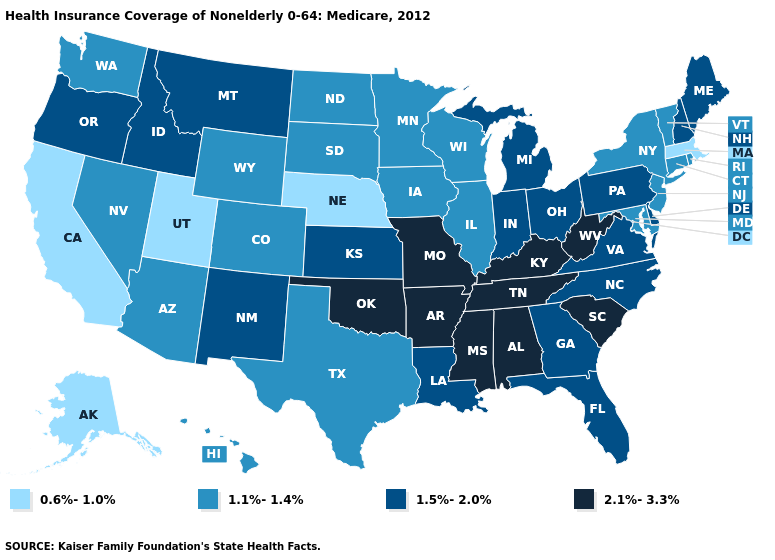What is the value of Mississippi?
Quick response, please. 2.1%-3.3%. Is the legend a continuous bar?
Give a very brief answer. No. Among the states that border Iowa , which have the highest value?
Keep it brief. Missouri. Does Delaware have the lowest value in the South?
Concise answer only. No. Which states have the highest value in the USA?
Answer briefly. Alabama, Arkansas, Kentucky, Mississippi, Missouri, Oklahoma, South Carolina, Tennessee, West Virginia. What is the value of New Jersey?
Give a very brief answer. 1.1%-1.4%. Does South Dakota have the lowest value in the MidWest?
Be succinct. No. What is the highest value in states that border Florida?
Keep it brief. 2.1%-3.3%. Name the states that have a value in the range 1.5%-2.0%?
Answer briefly. Delaware, Florida, Georgia, Idaho, Indiana, Kansas, Louisiana, Maine, Michigan, Montana, New Hampshire, New Mexico, North Carolina, Ohio, Oregon, Pennsylvania, Virginia. Among the states that border Utah , does Arizona have the lowest value?
Write a very short answer. Yes. What is the value of South Dakota?
Be succinct. 1.1%-1.4%. Name the states that have a value in the range 1.5%-2.0%?
Quick response, please. Delaware, Florida, Georgia, Idaho, Indiana, Kansas, Louisiana, Maine, Michigan, Montana, New Hampshire, New Mexico, North Carolina, Ohio, Oregon, Pennsylvania, Virginia. Name the states that have a value in the range 1.1%-1.4%?
Answer briefly. Arizona, Colorado, Connecticut, Hawaii, Illinois, Iowa, Maryland, Minnesota, Nevada, New Jersey, New York, North Dakota, Rhode Island, South Dakota, Texas, Vermont, Washington, Wisconsin, Wyoming. Name the states that have a value in the range 2.1%-3.3%?
Concise answer only. Alabama, Arkansas, Kentucky, Mississippi, Missouri, Oklahoma, South Carolina, Tennessee, West Virginia. Name the states that have a value in the range 1.5%-2.0%?
Concise answer only. Delaware, Florida, Georgia, Idaho, Indiana, Kansas, Louisiana, Maine, Michigan, Montana, New Hampshire, New Mexico, North Carolina, Ohio, Oregon, Pennsylvania, Virginia. 